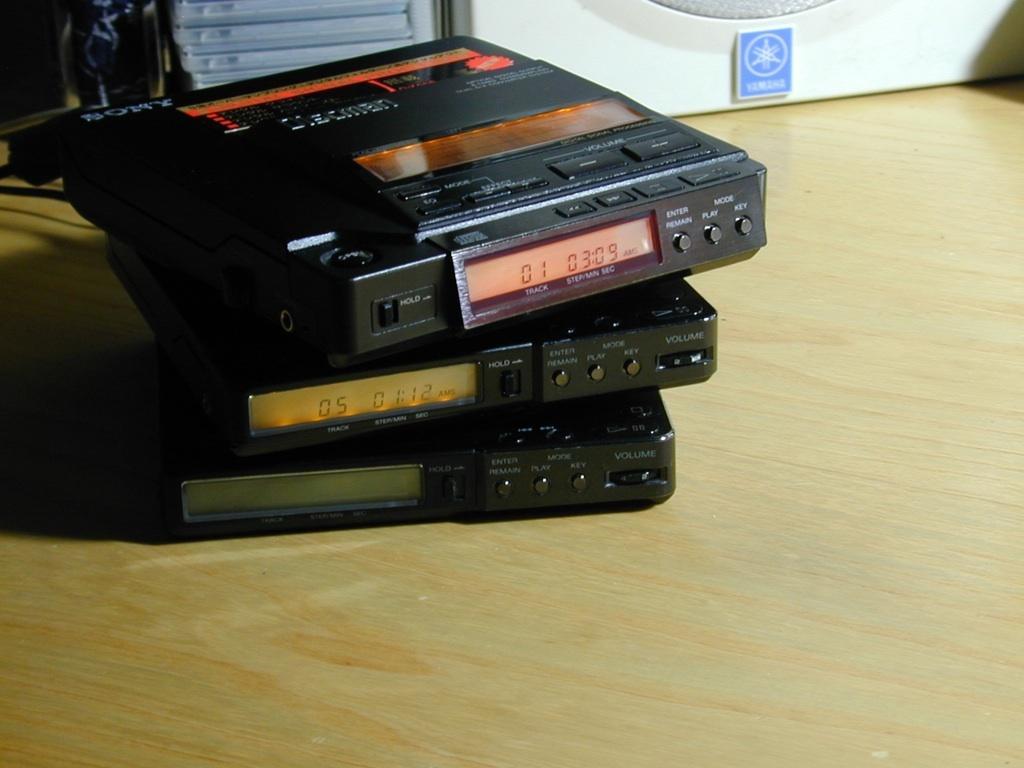Describe this image in one or two sentences. In this image there are a few electronic devices on the wooden surface. There are buttons, digital display boards and text on the devices. Behind it there are boxes. 